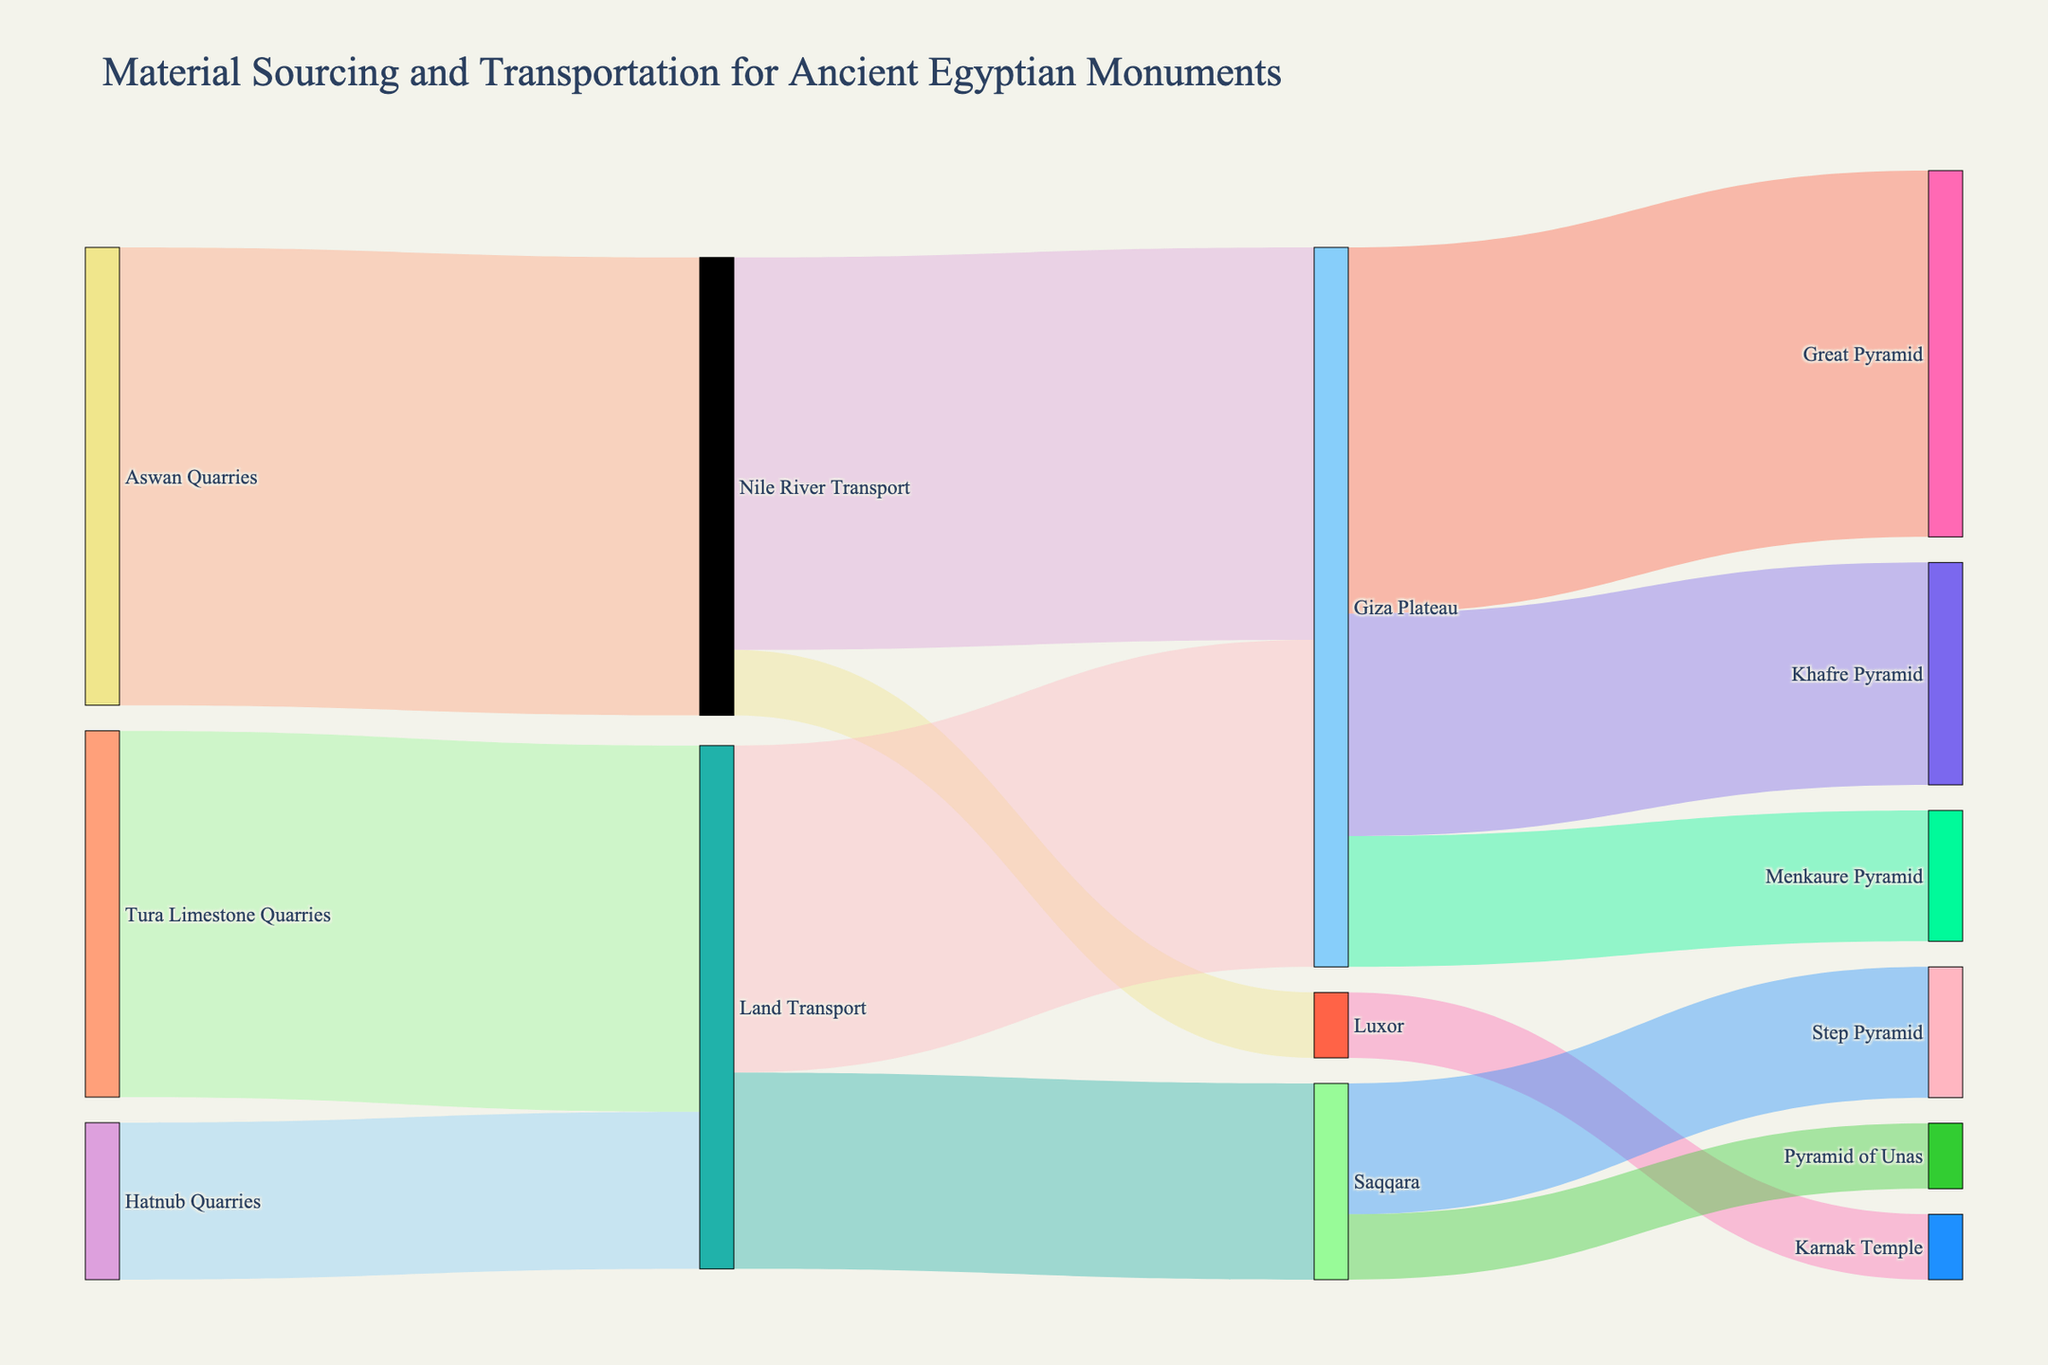what is the total number of connections starting from the quarries? Count the links originating from "Aswan Quarries," "Tura Limestone Quarries," and "Hatnub Quarries." Aswan: 1, Tura: 1, Hatnub: 1. Total = 3
Answer: 3 Which monument received the most material? Look at the target nodes and identify the monument with the highest incoming value. The Great Pyramid has an incoming value of 2800 from Giza Plateau.
Answer: The Great Pyramid How much material was transported via the Nile River? Sum the values of connections related to the "Nile River Transport" node. (3500 (Aswan) + 3000 (to Giza Plateau) + 500 (to Luxor)) = 7000
Answer: 7000 What is the difference in material transported to Saqqara and Luxor? Saqqara received 1500 (Land Transport) while Luxor received 500 (Nile River Transport). Difference: 1500 - 500 = 1000
Answer: 1000 Which quarry sent the most material? Compare the values of material sourced from each quarry. Aswan: 3500, Tura: 2800, Hatnub: 1200. Aswan Quarries sent the most.
Answer: Aswan Quarries What is the sum of materials received by Giza Plateau from all sources? Add up all values targeting "Giza Plateau": 3000 (Nile River Transport) + 2500 (Land Transport) = 5500
Answer: 5500 How many different monuments are represented in the diagram? Count the target nodes that indicate monuments: Great Pyramid, Khafre Pyramid, Menkaure Pyramid, Karnak Temple, Step Pyramid, Pyramid of Unas. There are 6.
Answer: 6 If the material transport from Tura Limestone Quarries increased by 500, how much total material would be transported over land? Current Land Transport: 2800 (Tura) + 1200 (Hatnub) = 4000. With 500 increase from Tura, it becomes 4500.
Answer: 4500 